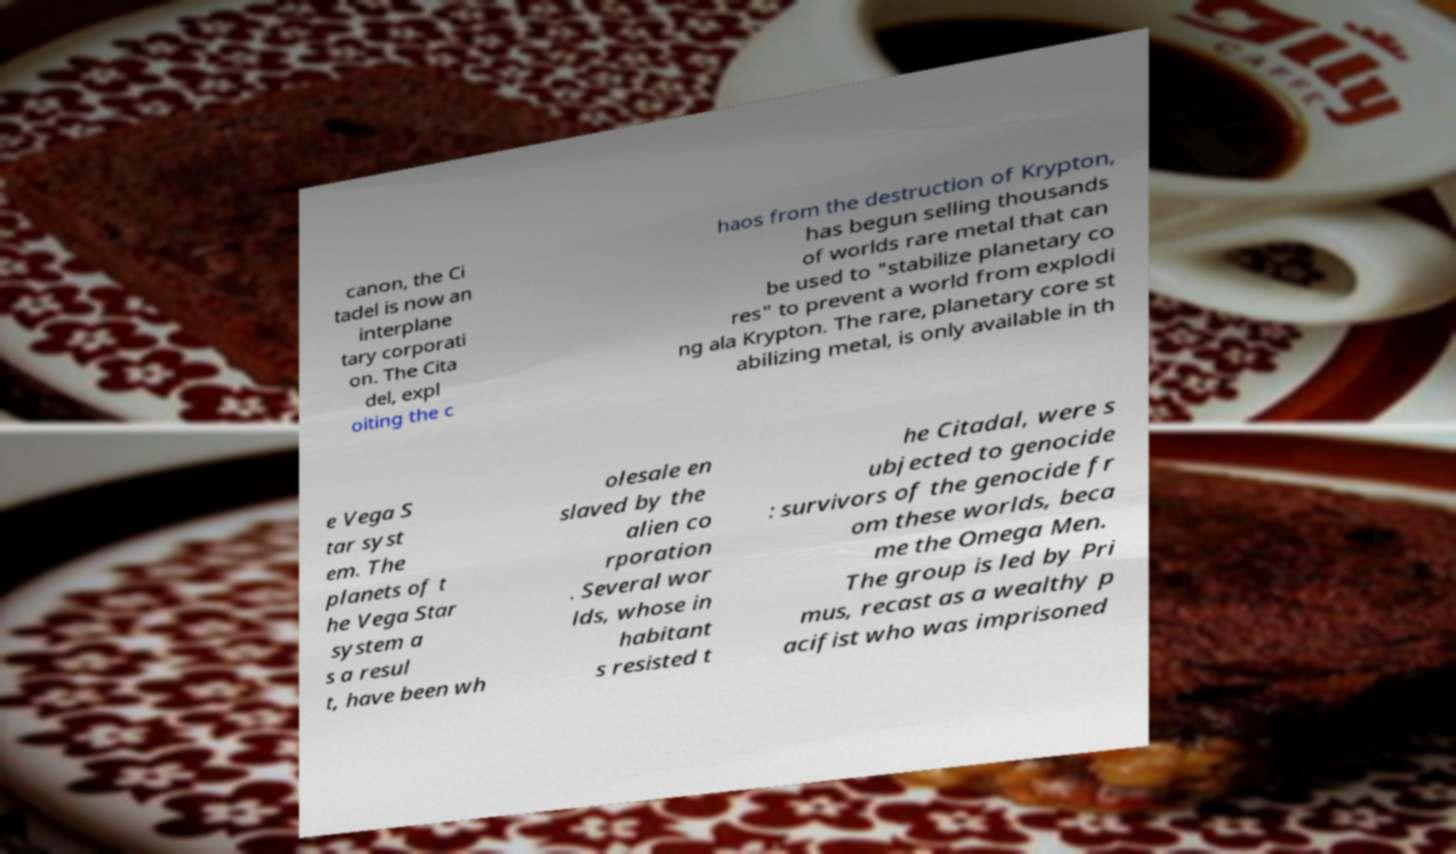Could you assist in decoding the text presented in this image and type it out clearly? canon, the Ci tadel is now an interplane tary corporati on. The Cita del, expl oiting the c haos from the destruction of Krypton, has begun selling thousands of worlds rare metal that can be used to "stabilize planetary co res" to prevent a world from explodi ng ala Krypton. The rare, planetary core st abilizing metal, is only available in th e Vega S tar syst em. The planets of t he Vega Star system a s a resul t, have been wh olesale en slaved by the alien co rporation . Several wor lds, whose in habitant s resisted t he Citadal, were s ubjected to genocide : survivors of the genocide fr om these worlds, beca me the Omega Men. The group is led by Pri mus, recast as a wealthy p acifist who was imprisoned 